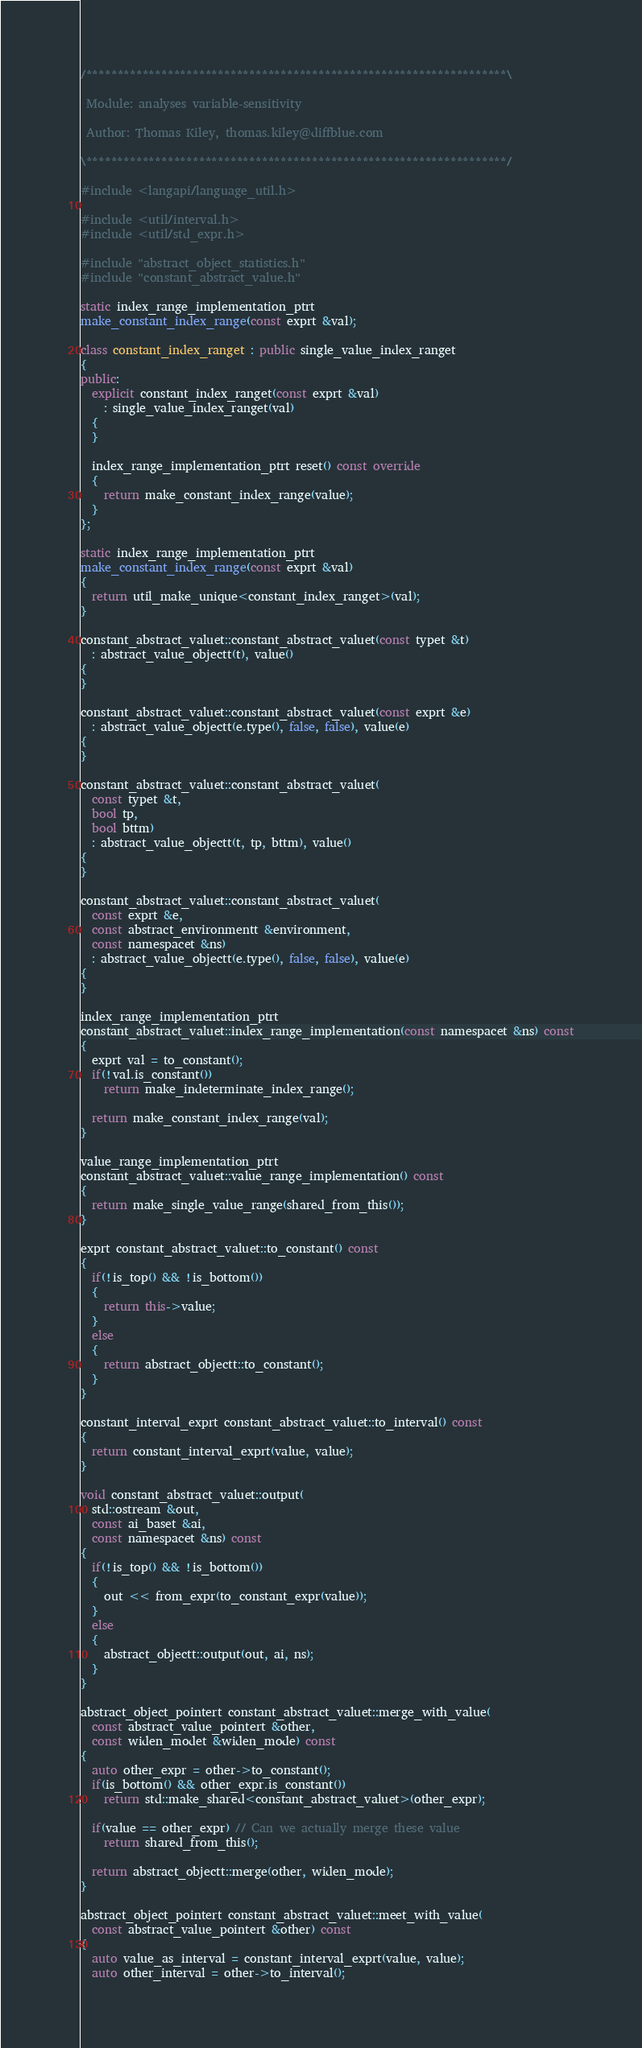Convert code to text. <code><loc_0><loc_0><loc_500><loc_500><_C++_>/*******************************************************************\

 Module: analyses variable-sensitivity

 Author: Thomas Kiley, thomas.kiley@diffblue.com

\*******************************************************************/

#include <langapi/language_util.h>

#include <util/interval.h>
#include <util/std_expr.h>

#include "abstract_object_statistics.h"
#include "constant_abstract_value.h"

static index_range_implementation_ptrt
make_constant_index_range(const exprt &val);

class constant_index_ranget : public single_value_index_ranget
{
public:
  explicit constant_index_ranget(const exprt &val)
    : single_value_index_ranget(val)
  {
  }

  index_range_implementation_ptrt reset() const override
  {
    return make_constant_index_range(value);
  }
};

static index_range_implementation_ptrt
make_constant_index_range(const exprt &val)
{
  return util_make_unique<constant_index_ranget>(val);
}

constant_abstract_valuet::constant_abstract_valuet(const typet &t)
  : abstract_value_objectt(t), value()
{
}

constant_abstract_valuet::constant_abstract_valuet(const exprt &e)
  : abstract_value_objectt(e.type(), false, false), value(e)
{
}

constant_abstract_valuet::constant_abstract_valuet(
  const typet &t,
  bool tp,
  bool bttm)
  : abstract_value_objectt(t, tp, bttm), value()
{
}

constant_abstract_valuet::constant_abstract_valuet(
  const exprt &e,
  const abstract_environmentt &environment,
  const namespacet &ns)
  : abstract_value_objectt(e.type(), false, false), value(e)
{
}

index_range_implementation_ptrt
constant_abstract_valuet::index_range_implementation(const namespacet &ns) const
{
  exprt val = to_constant();
  if(!val.is_constant())
    return make_indeterminate_index_range();

  return make_constant_index_range(val);
}

value_range_implementation_ptrt
constant_abstract_valuet::value_range_implementation() const
{
  return make_single_value_range(shared_from_this());
}

exprt constant_abstract_valuet::to_constant() const
{
  if(!is_top() && !is_bottom())
  {
    return this->value;
  }
  else
  {
    return abstract_objectt::to_constant();
  }
}

constant_interval_exprt constant_abstract_valuet::to_interval() const
{
  return constant_interval_exprt(value, value);
}

void constant_abstract_valuet::output(
  std::ostream &out,
  const ai_baset &ai,
  const namespacet &ns) const
{
  if(!is_top() && !is_bottom())
  {
    out << from_expr(to_constant_expr(value));
  }
  else
  {
    abstract_objectt::output(out, ai, ns);
  }
}

abstract_object_pointert constant_abstract_valuet::merge_with_value(
  const abstract_value_pointert &other,
  const widen_modet &widen_mode) const
{
  auto other_expr = other->to_constant();
  if(is_bottom() && other_expr.is_constant())
    return std::make_shared<constant_abstract_valuet>(other_expr);

  if(value == other_expr) // Can we actually merge these value
    return shared_from_this();

  return abstract_objectt::merge(other, widen_mode);
}

abstract_object_pointert constant_abstract_valuet::meet_with_value(
  const abstract_value_pointert &other) const
{
  auto value_as_interval = constant_interval_exprt(value, value);
  auto other_interval = other->to_interval();
</code> 